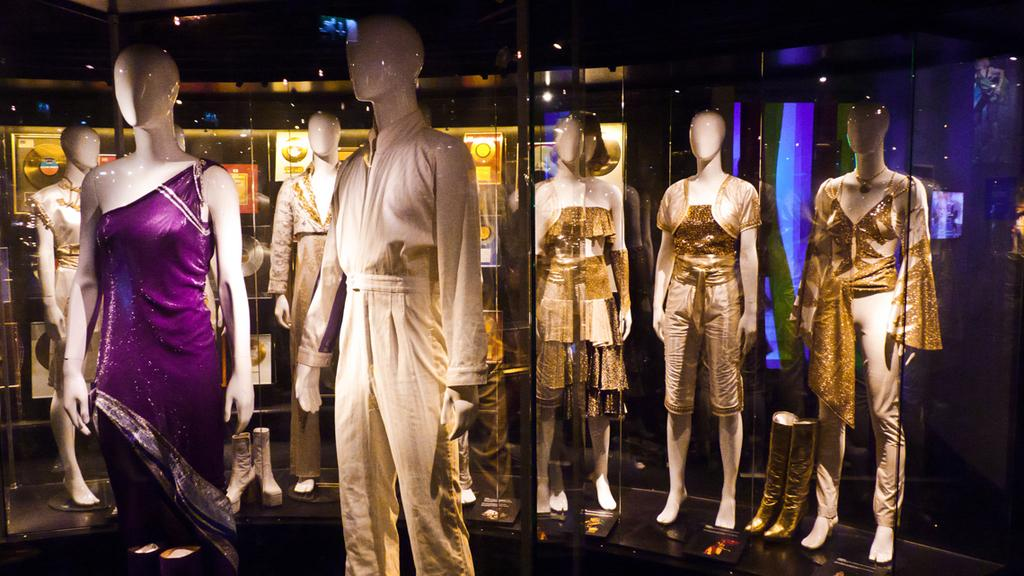What objects are present in the image? There are mannequins in the image. How are the mannequins positioned? The mannequins are placed on the floor. What are the mannequins wearing? The mannequins have dresses on them. What can be seen in the background of the image? There is a glass wall in the background of the image. What is the source of light behind the glass wall? There is a light focus visible behind the glass wall. What is the chance of winning the war in the image? There is no reference to a war or any chance of winning in the image. 